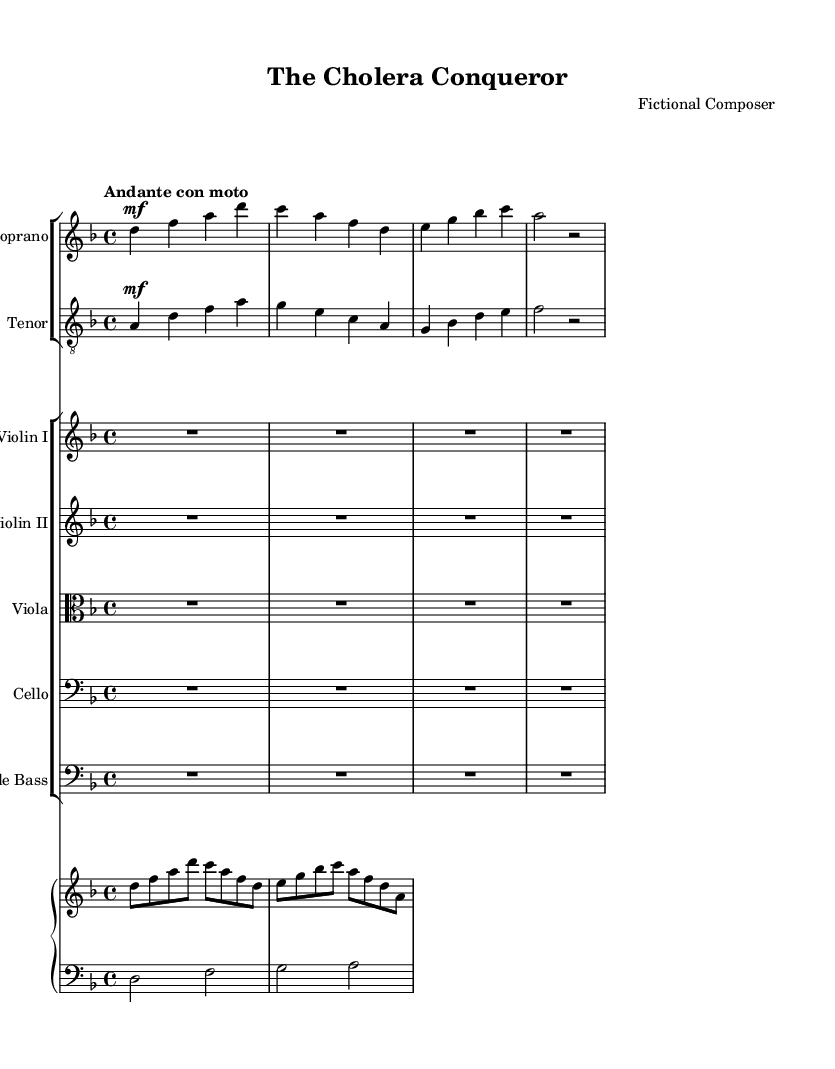What is the key signature of this music? The key signature is indicated before the first measure and consists of one flat (B♭), which confirms that the key is D minor.
Answer: D minor What is the time signature of the piece? The time signature is the number of beats in a measure, which is shown at the beginning of the score. It shows 4 beats per measure, thus indicating a quadruple meter.
Answer: 4/4 What is the tempo marking for this piece? The tempo marking is found at the beginning of the score, indicating the speed at which the piece should be played. It states "Andante con moto," which suggests a moderate pace with some movement.
Answer: Andante con moto Which two voices are featured in the opening section? From the score, the two voices labeled at the start are "Soprano" and "Tenor," which indicate the specific vocal parts being performed.
Answer: Soprano and Tenor What thematic element does the lyric in the soprano's part highlight? The soprano's lyric "Through London’s streets, a doctor walks" suggests a narrative element focusing on the journey of a doctor, which aligns with the dramatic theme of the opera.
Answer: The journey of a doctor How is the musical texture created in the arrangement? The score consists of multiple instruments including strings and piano, combined with two vocal parts, which layers the sound and creates a rich texture typical in opera.
Answer: Rich texture What is the function of the piano in this piece? The piano's role includes both rhythmic and harmonic support, providing accompaniment to the vocal lines while also enhancing the dramatic atmosphere.
Answer: Accompaniment 